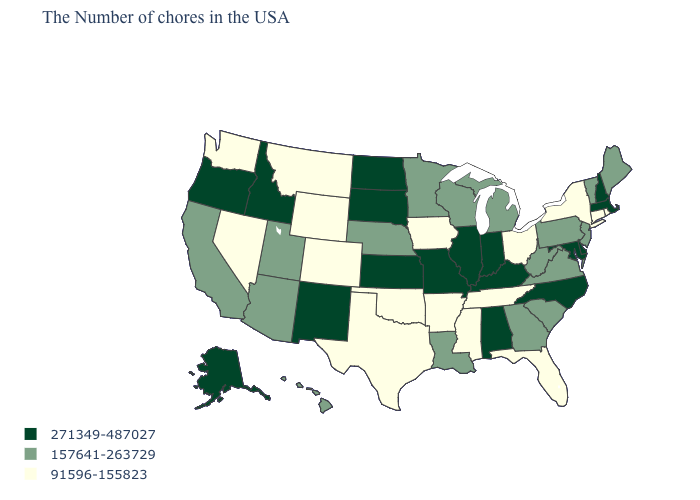What is the lowest value in the USA?
Short answer required. 91596-155823. Does South Dakota have the lowest value in the MidWest?
Quick response, please. No. Name the states that have a value in the range 271349-487027?
Concise answer only. Massachusetts, New Hampshire, Delaware, Maryland, North Carolina, Kentucky, Indiana, Alabama, Illinois, Missouri, Kansas, South Dakota, North Dakota, New Mexico, Idaho, Oregon, Alaska. Which states hav the highest value in the South?
Keep it brief. Delaware, Maryland, North Carolina, Kentucky, Alabama. What is the value of Kansas?
Answer briefly. 271349-487027. Does South Carolina have the lowest value in the USA?
Concise answer only. No. What is the highest value in the USA?
Keep it brief. 271349-487027. What is the highest value in states that border Idaho?
Give a very brief answer. 271349-487027. Does Alaska have the highest value in the USA?
Give a very brief answer. Yes. How many symbols are there in the legend?
Concise answer only. 3. Does the map have missing data?
Short answer required. No. Which states have the highest value in the USA?
Write a very short answer. Massachusetts, New Hampshire, Delaware, Maryland, North Carolina, Kentucky, Indiana, Alabama, Illinois, Missouri, Kansas, South Dakota, North Dakota, New Mexico, Idaho, Oregon, Alaska. Among the states that border New Hampshire , which have the highest value?
Answer briefly. Massachusetts. Name the states that have a value in the range 91596-155823?
Be succinct. Rhode Island, Connecticut, New York, Ohio, Florida, Tennessee, Mississippi, Arkansas, Iowa, Oklahoma, Texas, Wyoming, Colorado, Montana, Nevada, Washington. How many symbols are there in the legend?
Give a very brief answer. 3. 